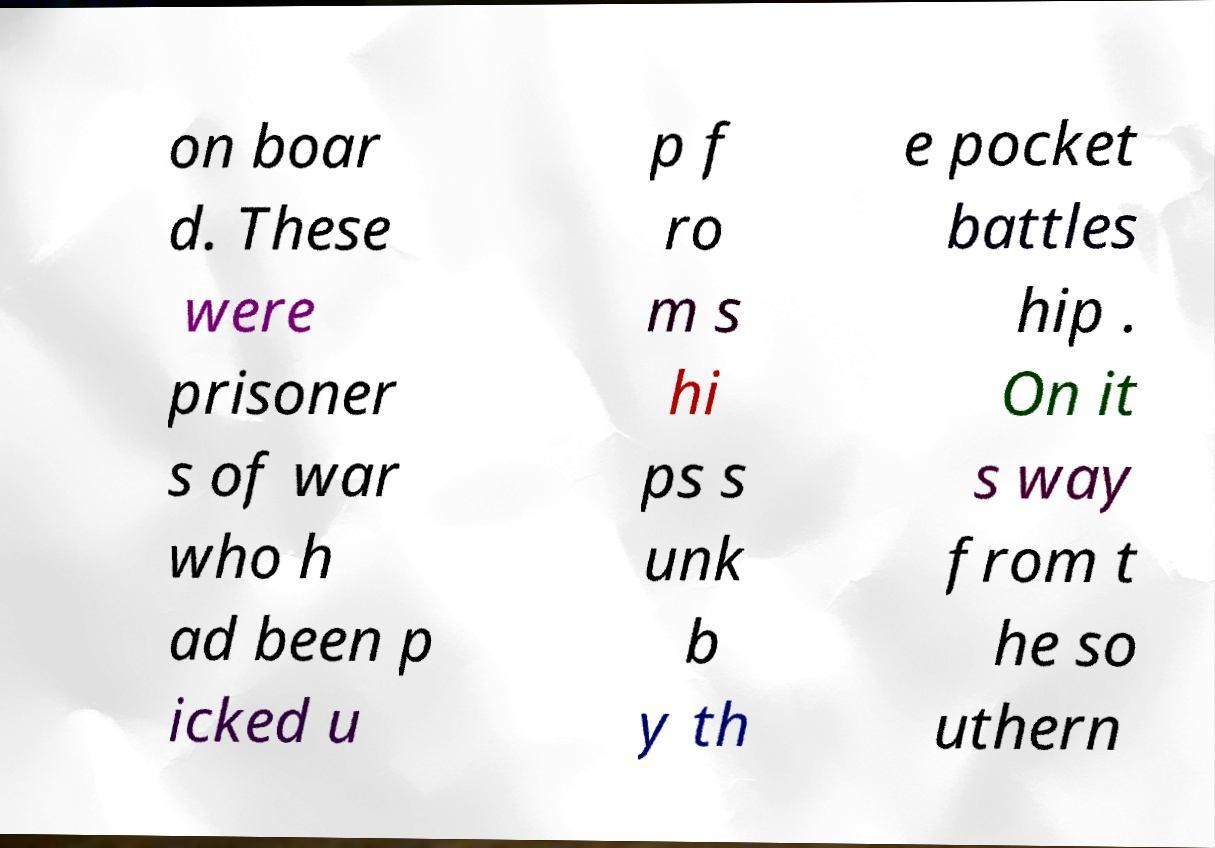For documentation purposes, I need the text within this image transcribed. Could you provide that? on boar d. These were prisoner s of war who h ad been p icked u p f ro m s hi ps s unk b y th e pocket battles hip . On it s way from t he so uthern 